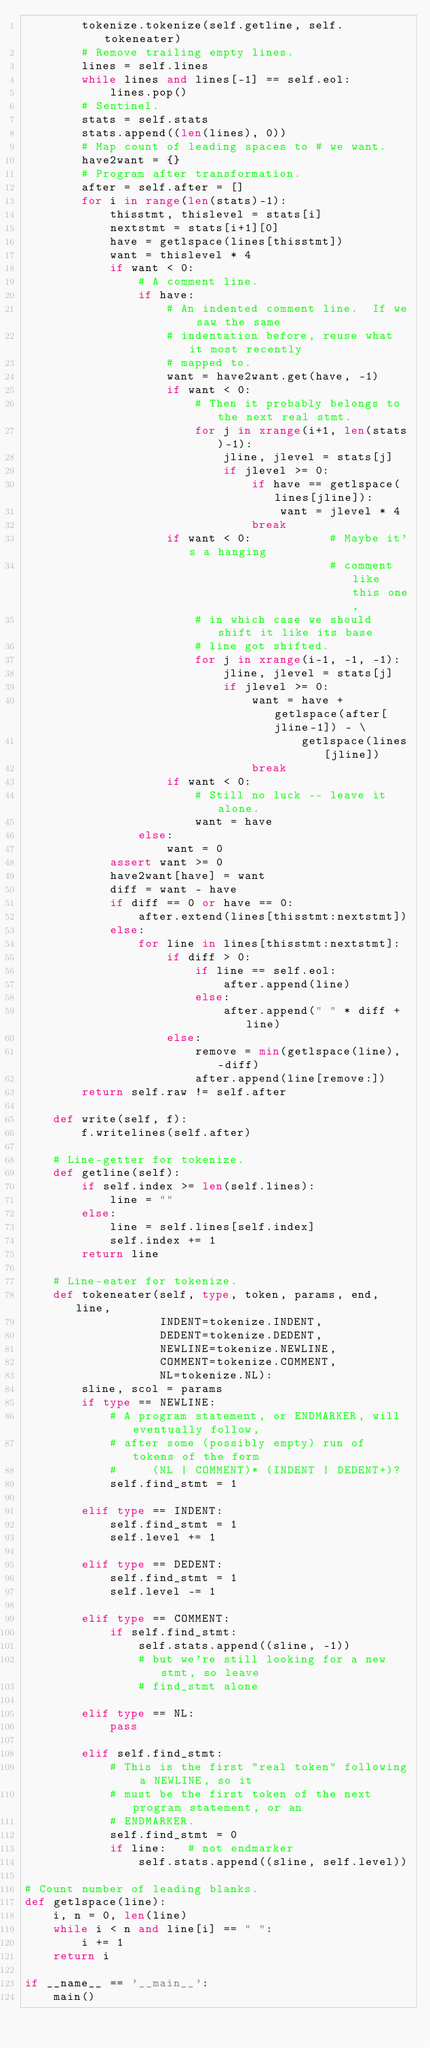Convert code to text. <code><loc_0><loc_0><loc_500><loc_500><_Python_>        tokenize.tokenize(self.getline, self.tokeneater)
        # Remove trailing empty lines.
        lines = self.lines
        while lines and lines[-1] == self.eol:
            lines.pop()
        # Sentinel.
        stats = self.stats
        stats.append((len(lines), 0))
        # Map count of leading spaces to # we want.
        have2want = {}
        # Program after transformation.
        after = self.after = []
        for i in range(len(stats)-1):
            thisstmt, thislevel = stats[i]
            nextstmt = stats[i+1][0]
            have = getlspace(lines[thisstmt])
            want = thislevel * 4
            if want < 0:
                # A comment line.
                if have:
                    # An indented comment line.  If we saw the same
                    # indentation before, reuse what it most recently
                    # mapped to.
                    want = have2want.get(have, -1)
                    if want < 0:
                        # Then it probably belongs to the next real stmt.
                        for j in xrange(i+1, len(stats)-1):
                            jline, jlevel = stats[j]
                            if jlevel >= 0:
                                if have == getlspace(lines[jline]):
                                    want = jlevel * 4
                                break
                    if want < 0:           # Maybe it's a hanging
                                           # comment like this one,
                        # in which case we should shift it like its base
                        # line got shifted.
                        for j in xrange(i-1, -1, -1):
                            jline, jlevel = stats[j]
                            if jlevel >= 0:
                                want = have + getlspace(after[jline-1]) - \
                                       getlspace(lines[jline])
                                break
                    if want < 0:
                        # Still no luck -- leave it alone.
                        want = have
                else:
                    want = 0
            assert want >= 0
            have2want[have] = want
            diff = want - have
            if diff == 0 or have == 0:
                after.extend(lines[thisstmt:nextstmt])
            else:
                for line in lines[thisstmt:nextstmt]:
                    if diff > 0:
                        if line == self.eol:
                            after.append(line)
                        else:
                            after.append(" " * diff + line)
                    else:
                        remove = min(getlspace(line), -diff)
                        after.append(line[remove:])
        return self.raw != self.after

    def write(self, f):
        f.writelines(self.after)

    # Line-getter for tokenize.
    def getline(self):
        if self.index >= len(self.lines):
            line = ""
        else:
            line = self.lines[self.index]
            self.index += 1
        return line

    # Line-eater for tokenize.
    def tokeneater(self, type, token, params, end, line,
                   INDENT=tokenize.INDENT,
                   DEDENT=tokenize.DEDENT,
                   NEWLINE=tokenize.NEWLINE,
                   COMMENT=tokenize.COMMENT,
                   NL=tokenize.NL):
        sline, scol = params
        if type == NEWLINE:
            # A program statement, or ENDMARKER, will eventually follow,
            # after some (possibly empty) run of tokens of the form
            #     (NL | COMMENT)* (INDENT | DEDENT+)?
            self.find_stmt = 1

        elif type == INDENT:
            self.find_stmt = 1
            self.level += 1

        elif type == DEDENT:
            self.find_stmt = 1
            self.level -= 1

        elif type == COMMENT:
            if self.find_stmt:
                self.stats.append((sline, -1))
                # but we're still looking for a new stmt, so leave
                # find_stmt alone

        elif type == NL:
            pass

        elif self.find_stmt:
            # This is the first "real token" following a NEWLINE, so it
            # must be the first token of the next program statement, or an
            # ENDMARKER.
            self.find_stmt = 0
            if line:   # not endmarker
                self.stats.append((sline, self.level))

# Count number of leading blanks.
def getlspace(line):
    i, n = 0, len(line)
    while i < n and line[i] == " ":
        i += 1
    return i

if __name__ == '__main__':
    main()

</code> 